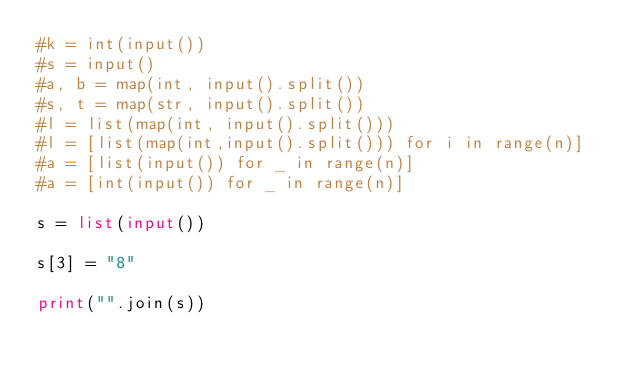Convert code to text. <code><loc_0><loc_0><loc_500><loc_500><_Python_>#k = int(input())
#s = input()
#a, b = map(int, input().split())
#s, t = map(str, input().split())
#l = list(map(int, input().split()))
#l = [list(map(int,input().split())) for i in range(n)]
#a = [list(input()) for _ in range(n)]
#a = [int(input()) for _ in range(n)]

s = list(input())

s[3] = "8"

print("".join(s))



</code> 